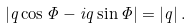<formula> <loc_0><loc_0><loc_500><loc_500>\left | q \cos \Phi - i q \sin \Phi \right | = \left | q \right | .</formula> 